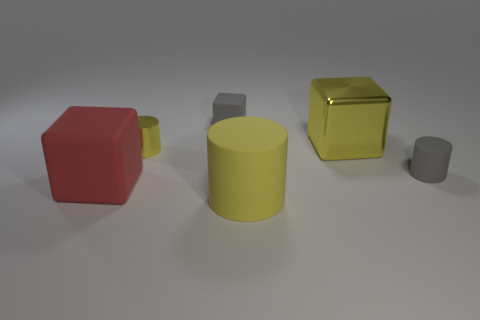What number of large rubber objects are the same color as the big shiny cube?
Your answer should be very brief. 1. There is a yellow object that is behind the metal cylinder; does it have the same size as the tiny yellow object?
Give a very brief answer. No. What color is the tiny object that is both to the left of the gray cylinder and in front of the large yellow block?
Make the answer very short. Yellow. What number of things are either purple metal objects or tiny objects that are in front of the gray block?
Give a very brief answer. 2. What is the yellow cylinder in front of the tiny gray thing that is in front of the small rubber thing that is behind the tiny metallic thing made of?
Offer a terse response. Rubber. Are there any other things that are the same material as the tiny gray cylinder?
Provide a short and direct response. Yes. Do the large block on the right side of the red cube and the tiny cube have the same color?
Make the answer very short. No. How many brown things are small shiny cylinders or large shiny objects?
Make the answer very short. 0. How many other objects are there of the same shape as the big yellow rubber object?
Your answer should be very brief. 2. Do the tiny yellow cylinder and the big yellow cylinder have the same material?
Keep it short and to the point. No. 